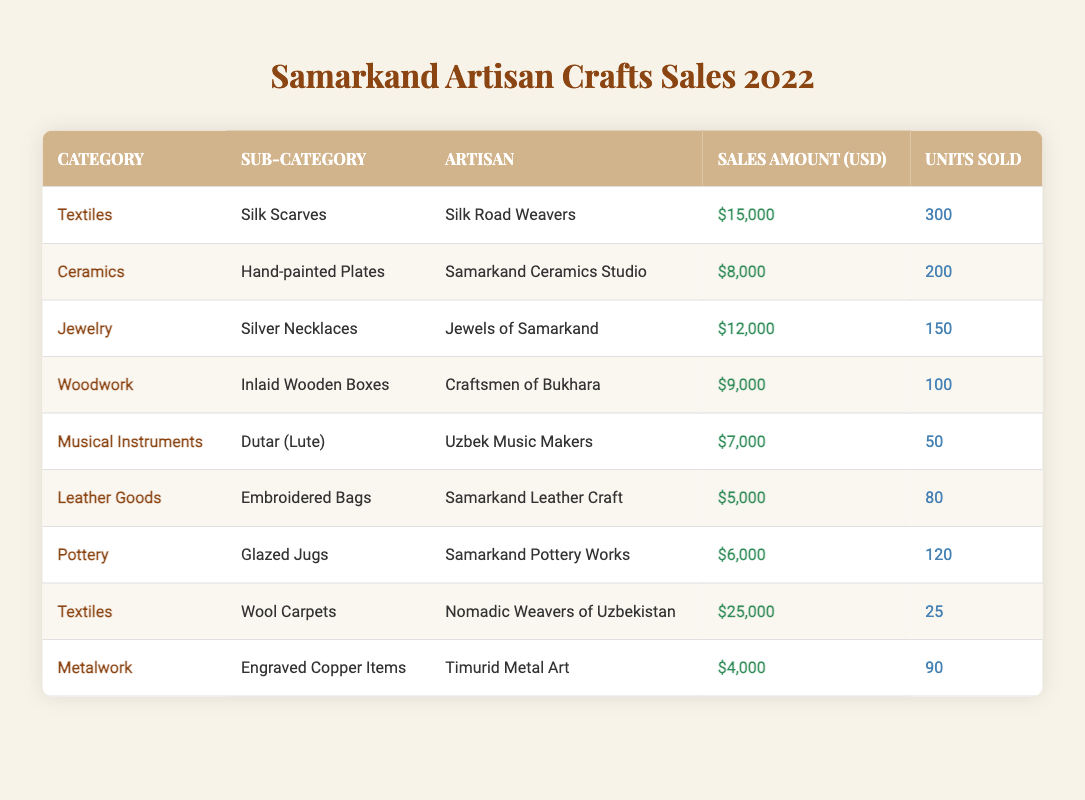What is the highest sales amount recorded in the table? The highest sales amount is found in the Textiles category for Wool Carpets, which shows a sales amount of $25,000.
Answer: $25,000 Which artisan sold the most units in 2022? The artisan who sold the most units is Silk Road Weavers with 300 units sold of Silk Scarves.
Answer: Silk Road Weavers What was the total sales amount for the Pottery category? The sales amount for the Pottery category from the table shows Glazed Jugs sold for $6,000, and since it is the only item in that category, the total is $6,000.
Answer: $6,000 How many total units were sold for all Jewelry items? To find the total units sold for all Jewelry items, we look at only the Silver Necklaces in the table, which sold 150 units. Therefore, the total is 150.
Answer: 150 Are there any artisan crafts from the Metalwork category that exceeded $5,000 in sales? To check this, we see the Metalwork category’s sales from Timurid Metal Art is $4,000, which does not exceed $5,000. Thus, there are no crafts that exceeded that amount.
Answer: No What is the average sales amount of all crafts listed? To find the average, we first sum all the sales amounts: $15,000 + $8,000 + $12,000 + $9,000 + $7,000 + $5,000 + $6,000 + $25,000 + $4,000 = $86,000. The total number of items is 9, so the average is $86,000 / 9 = $9,555.56.
Answer: $9,555.56 How many more units of Silk Scarves were sold compared to Embroidered Bags? Silk Scarves had 300 units sold while Embroidered Bags had 80 units sold. The difference in units is 300 - 80 = 220.
Answer: 220 Which category had the least number of units sold? In the table, the category with the least units sold is Textiles, with Wool Carpets selling only 25 units.
Answer: Textiles Did any artisan crafts in the table sell fewer than 100 units? Yes, the Dutar (lute) sold 50 units and the Wool Carpets sold 25 units, both of which are less than 100.
Answer: Yes How much sales did the Samarkand Leather Craft generate compared to the Craftsmen of Bukhara? Samarkand Leather Craft generated $5,000 and Craftsmen of Bukhara generated $9,000. The difference is $9,000 - $5,000 = $4,000, indicating Craftsmen of Bukhara had higher sales by that amount.
Answer: $4,000 What is the combined sales amount of the Textiles category? The sales amounts for the Textiles category include Silk Scarves ($15,000) and Wool Carpets ($25,000). Adding these together gives $15,000 + $25,000 = $40,000.
Answer: $40,000 